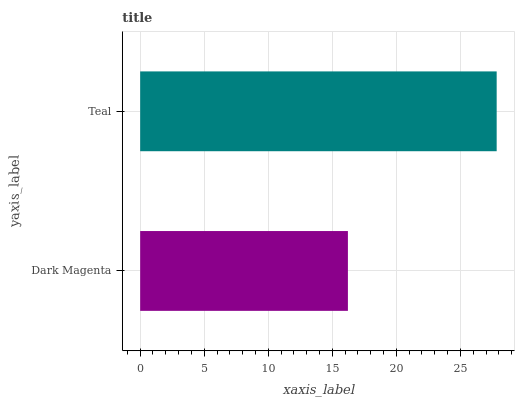Is Dark Magenta the minimum?
Answer yes or no. Yes. Is Teal the maximum?
Answer yes or no. Yes. Is Teal the minimum?
Answer yes or no. No. Is Teal greater than Dark Magenta?
Answer yes or no. Yes. Is Dark Magenta less than Teal?
Answer yes or no. Yes. Is Dark Magenta greater than Teal?
Answer yes or no. No. Is Teal less than Dark Magenta?
Answer yes or no. No. Is Teal the high median?
Answer yes or no. Yes. Is Dark Magenta the low median?
Answer yes or no. Yes. Is Dark Magenta the high median?
Answer yes or no. No. Is Teal the low median?
Answer yes or no. No. 